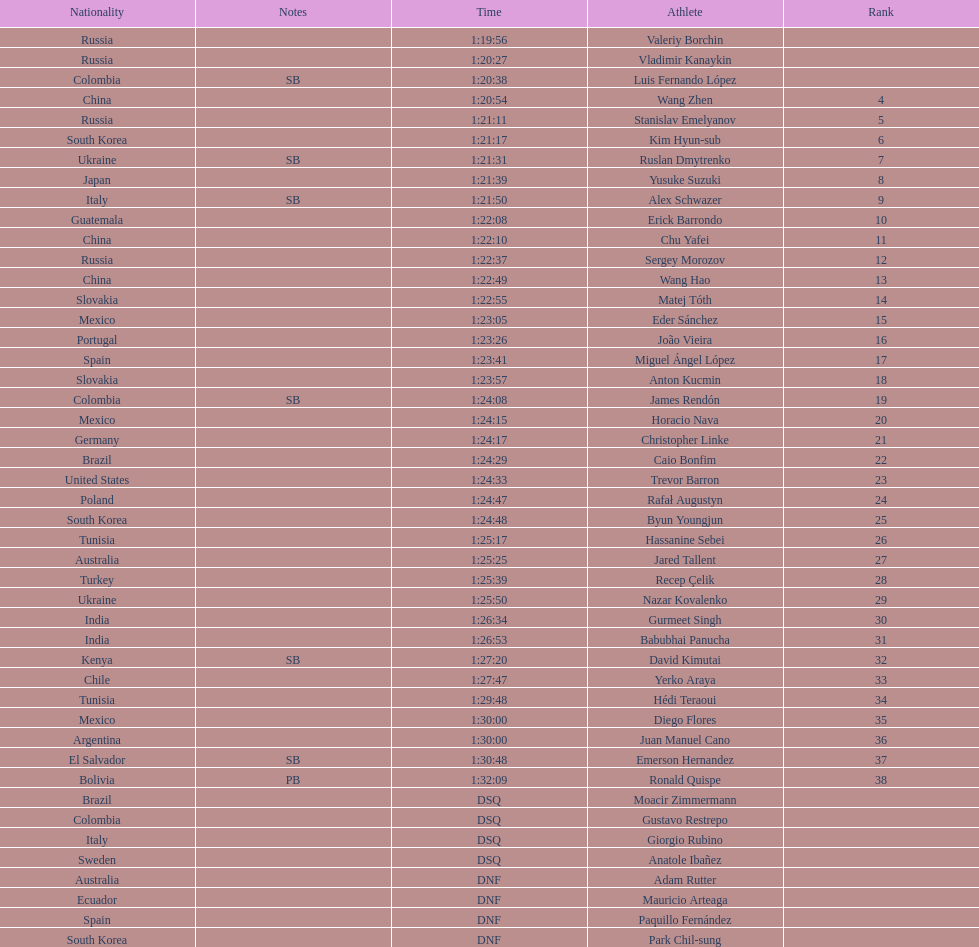Can you parse all the data within this table? {'header': ['Nationality', 'Notes', 'Time', 'Athlete', 'Rank'], 'rows': [['Russia', '', '1:19:56', 'Valeriy Borchin', ''], ['Russia', '', '1:20:27', 'Vladimir Kanaykin', ''], ['Colombia', 'SB', '1:20:38', 'Luis Fernando López', ''], ['China', '', '1:20:54', 'Wang Zhen', '4'], ['Russia', '', '1:21:11', 'Stanislav Emelyanov', '5'], ['South Korea', '', '1:21:17', 'Kim Hyun-sub', '6'], ['Ukraine', 'SB', '1:21:31', 'Ruslan Dmytrenko', '7'], ['Japan', '', '1:21:39', 'Yusuke Suzuki', '8'], ['Italy', 'SB', '1:21:50', 'Alex Schwazer', '9'], ['Guatemala', '', '1:22:08', 'Erick Barrondo', '10'], ['China', '', '1:22:10', 'Chu Yafei', '11'], ['Russia', '', '1:22:37', 'Sergey Morozov', '12'], ['China', '', '1:22:49', 'Wang Hao', '13'], ['Slovakia', '', '1:22:55', 'Matej Tóth', '14'], ['Mexico', '', '1:23:05', 'Eder Sánchez', '15'], ['Portugal', '', '1:23:26', 'João Vieira', '16'], ['Spain', '', '1:23:41', 'Miguel Ángel López', '17'], ['Slovakia', '', '1:23:57', 'Anton Kucmin', '18'], ['Colombia', 'SB', '1:24:08', 'James Rendón', '19'], ['Mexico', '', '1:24:15', 'Horacio Nava', '20'], ['Germany', '', '1:24:17', 'Christopher Linke', '21'], ['Brazil', '', '1:24:29', 'Caio Bonfim', '22'], ['United States', '', '1:24:33', 'Trevor Barron', '23'], ['Poland', '', '1:24:47', 'Rafał Augustyn', '24'], ['South Korea', '', '1:24:48', 'Byun Youngjun', '25'], ['Tunisia', '', '1:25:17', 'Hassanine Sebei', '26'], ['Australia', '', '1:25:25', 'Jared Tallent', '27'], ['Turkey', '', '1:25:39', 'Recep Çelik', '28'], ['Ukraine', '', '1:25:50', 'Nazar Kovalenko', '29'], ['India', '', '1:26:34', 'Gurmeet Singh', '30'], ['India', '', '1:26:53', 'Babubhai Panucha', '31'], ['Kenya', 'SB', '1:27:20', 'David Kimutai', '32'], ['Chile', '', '1:27:47', 'Yerko Araya', '33'], ['Tunisia', '', '1:29:48', 'Hédi Teraoui', '34'], ['Mexico', '', '1:30:00', 'Diego Flores', '35'], ['Argentina', '', '1:30:00', 'Juan Manuel Cano', '36'], ['El Salvador', 'SB', '1:30:48', 'Emerson Hernandez', '37'], ['Bolivia', 'PB', '1:32:09', 'Ronald Quispe', '38'], ['Brazil', '', 'DSQ', 'Moacir Zimmermann', ''], ['Colombia', '', 'DSQ', 'Gustavo Restrepo', ''], ['Italy', '', 'DSQ', 'Giorgio Rubino', ''], ['Sweden', '', 'DSQ', 'Anatole Ibañez', ''], ['Australia', '', 'DNF', 'Adam Rutter', ''], ['Ecuador', '', 'DNF', 'Mauricio Arteaga', ''], ['Spain', '', 'DNF', 'Paquillo Fernández', ''], ['South Korea', '', 'DNF', 'Park Chil-sung', '']]} Which competitor was ranked first? Valeriy Borchin. 